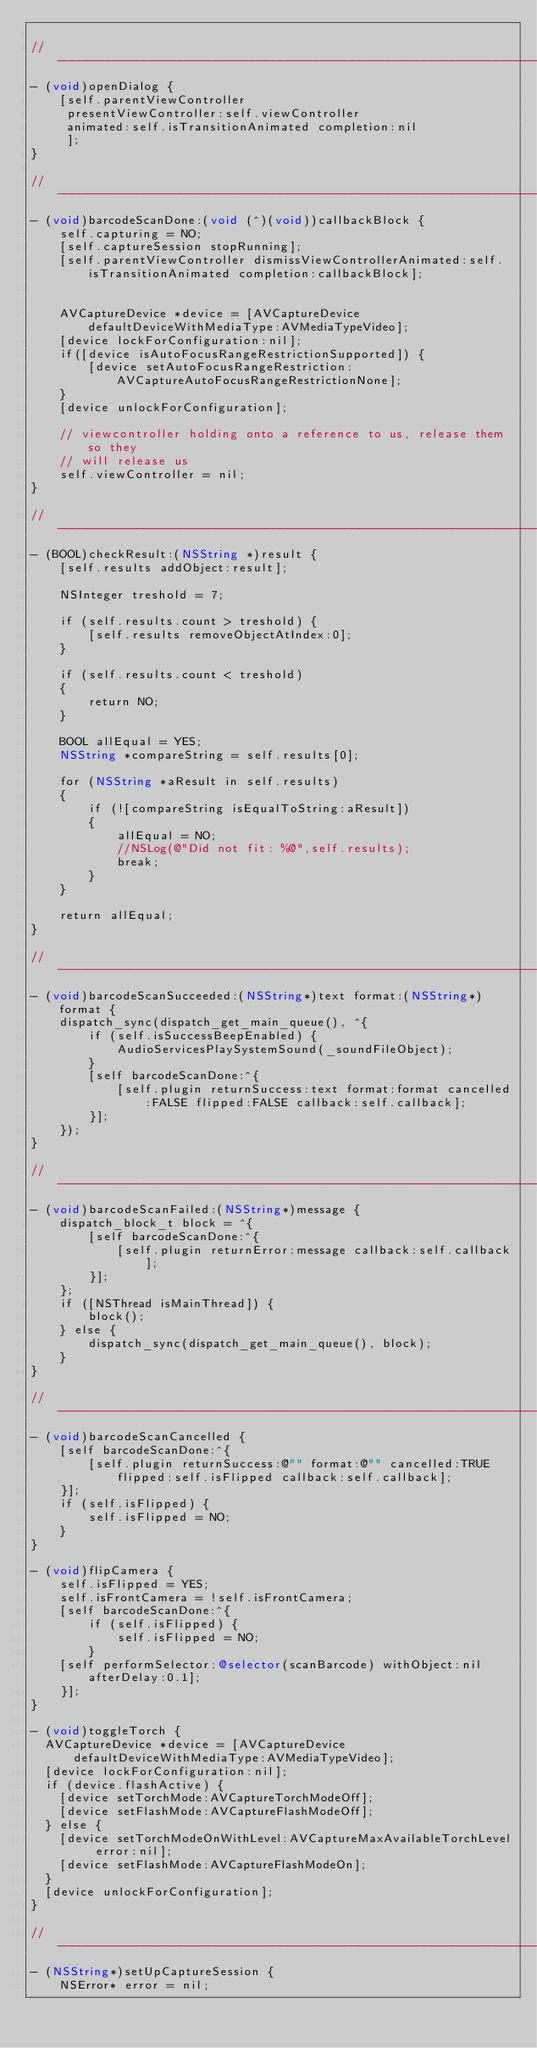Convert code to text. <code><loc_0><loc_0><loc_500><loc_500><_ObjectiveC_>
//--------------------------------------------------------------------------
- (void)openDialog {
    [self.parentViewController
     presentViewController:self.viewController
     animated:self.isTransitionAnimated completion:nil
     ];
}

//--------------------------------------------------------------------------
- (void)barcodeScanDone:(void (^)(void))callbackBlock {
    self.capturing = NO;
    [self.captureSession stopRunning];
    [self.parentViewController dismissViewControllerAnimated:self.isTransitionAnimated completion:callbackBlock];


    AVCaptureDevice *device = [AVCaptureDevice defaultDeviceWithMediaType:AVMediaTypeVideo];
    [device lockForConfiguration:nil];
    if([device isAutoFocusRangeRestrictionSupported]) {
        [device setAutoFocusRangeRestriction:AVCaptureAutoFocusRangeRestrictionNone];
    }
    [device unlockForConfiguration];

    // viewcontroller holding onto a reference to us, release them so they
    // will release us
    self.viewController = nil;
}

//--------------------------------------------------------------------------
- (BOOL)checkResult:(NSString *)result {
    [self.results addObject:result];

    NSInteger treshold = 7;

    if (self.results.count > treshold) {
        [self.results removeObjectAtIndex:0];
    }

    if (self.results.count < treshold)
    {
        return NO;
    }

    BOOL allEqual = YES;
    NSString *compareString = self.results[0];

    for (NSString *aResult in self.results)
    {
        if (![compareString isEqualToString:aResult])
        {
            allEqual = NO;
            //NSLog(@"Did not fit: %@",self.results);
            break;
        }
    }

    return allEqual;
}

//--------------------------------------------------------------------------
- (void)barcodeScanSucceeded:(NSString*)text format:(NSString*)format {
    dispatch_sync(dispatch_get_main_queue(), ^{
        if (self.isSuccessBeepEnabled) {
            AudioServicesPlaySystemSound(_soundFileObject);
        }
        [self barcodeScanDone:^{
            [self.plugin returnSuccess:text format:format cancelled:FALSE flipped:FALSE callback:self.callback];
        }];
    });
}

//--------------------------------------------------------------------------
- (void)barcodeScanFailed:(NSString*)message {
    dispatch_block_t block = ^{
        [self barcodeScanDone:^{
            [self.plugin returnError:message callback:self.callback];
        }];
    };
    if ([NSThread isMainThread]) {
        block();
    } else {
        dispatch_sync(dispatch_get_main_queue(), block);
    }
}

//--------------------------------------------------------------------------
- (void)barcodeScanCancelled {
    [self barcodeScanDone:^{
        [self.plugin returnSuccess:@"" format:@"" cancelled:TRUE flipped:self.isFlipped callback:self.callback];
    }];
    if (self.isFlipped) {
        self.isFlipped = NO;
    }
}

- (void)flipCamera {
    self.isFlipped = YES;
    self.isFrontCamera = !self.isFrontCamera;
    [self barcodeScanDone:^{
        if (self.isFlipped) {
            self.isFlipped = NO;
        }
    [self performSelector:@selector(scanBarcode) withObject:nil afterDelay:0.1];
    }];
}

- (void)toggleTorch {
  AVCaptureDevice *device = [AVCaptureDevice defaultDeviceWithMediaType:AVMediaTypeVideo];
  [device lockForConfiguration:nil];
  if (device.flashActive) {
    [device setTorchMode:AVCaptureTorchModeOff];
    [device setFlashMode:AVCaptureFlashModeOff];
  } else {
    [device setTorchModeOnWithLevel:AVCaptureMaxAvailableTorchLevel error:nil];
    [device setFlashMode:AVCaptureFlashModeOn];
  }
  [device unlockForConfiguration];
}

//--------------------------------------------------------------------------
- (NSString*)setUpCaptureSession {
    NSError* error = nil;
</code> 